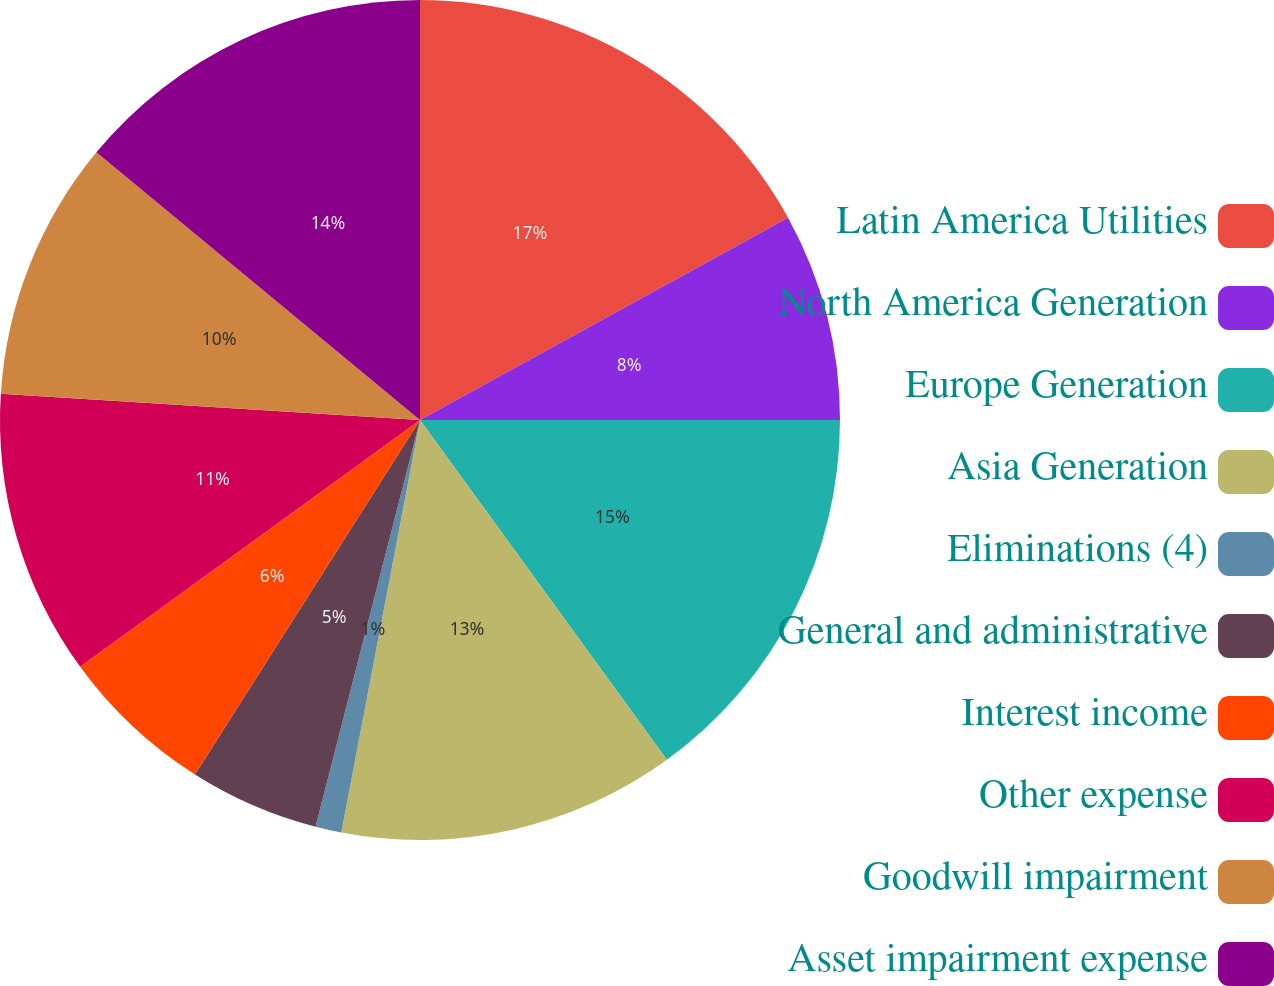<chart> <loc_0><loc_0><loc_500><loc_500><pie_chart><fcel>Latin America Utilities<fcel>North America Generation<fcel>Europe Generation<fcel>Asia Generation<fcel>Eliminations (4)<fcel>General and administrative<fcel>Interest income<fcel>Other expense<fcel>Goodwill impairment<fcel>Asset impairment expense<nl><fcel>17.0%<fcel>8.0%<fcel>15.0%<fcel>13.0%<fcel>1.0%<fcel>5.0%<fcel>6.0%<fcel>11.0%<fcel>10.0%<fcel>14.0%<nl></chart> 